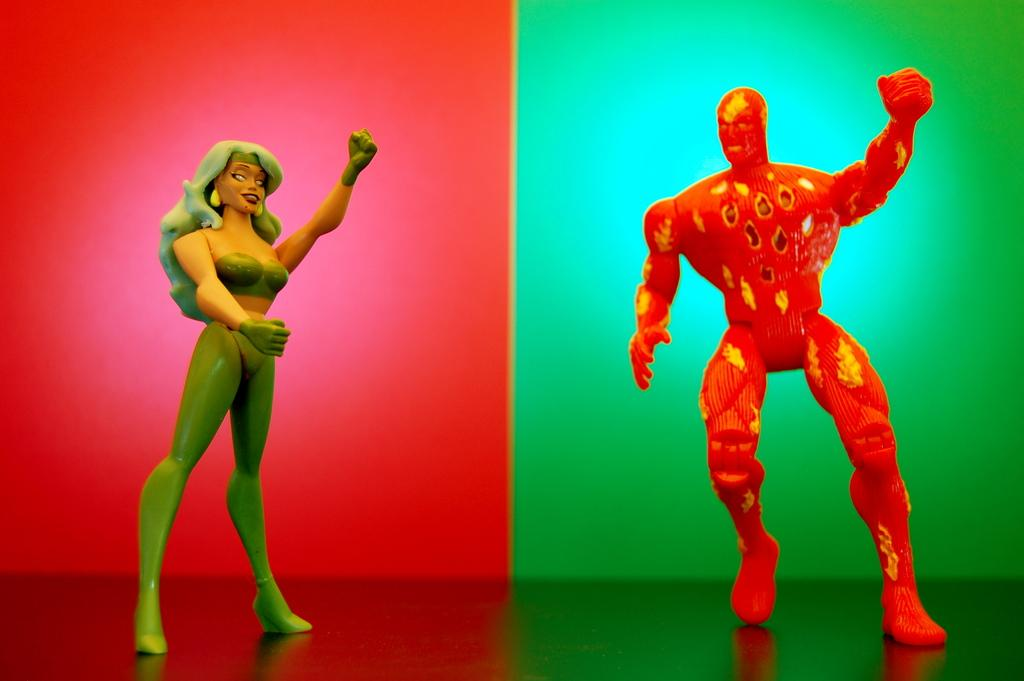What objects can be seen in the image? There are toys in the image. What colors are present in the background of the image? The background of the image has red and green colors. What surface is visible at the bottom of the image? There is a floor visible at the bottom of the image. What is the price of the wire in the image? There is no wire present in the image, so it is not possible to determine its price. 